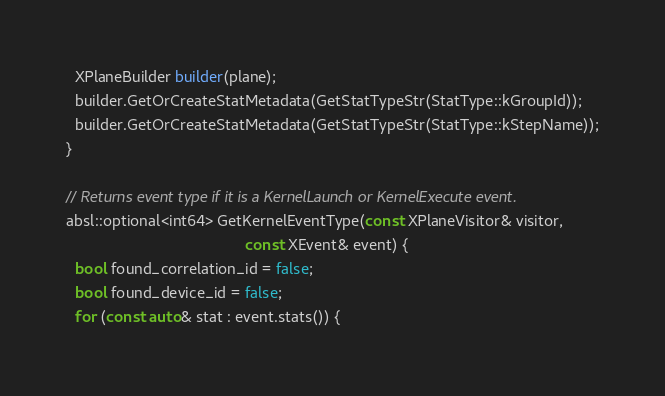<code> <loc_0><loc_0><loc_500><loc_500><_C++_>  XPlaneBuilder builder(plane);
  builder.GetOrCreateStatMetadata(GetStatTypeStr(StatType::kGroupId));
  builder.GetOrCreateStatMetadata(GetStatTypeStr(StatType::kStepName));
}

// Returns event type if it is a KernelLaunch or KernelExecute event.
absl::optional<int64> GetKernelEventType(const XPlaneVisitor& visitor,
                                         const XEvent& event) {
  bool found_correlation_id = false;
  bool found_device_id = false;
  for (const auto& stat : event.stats()) {</code> 